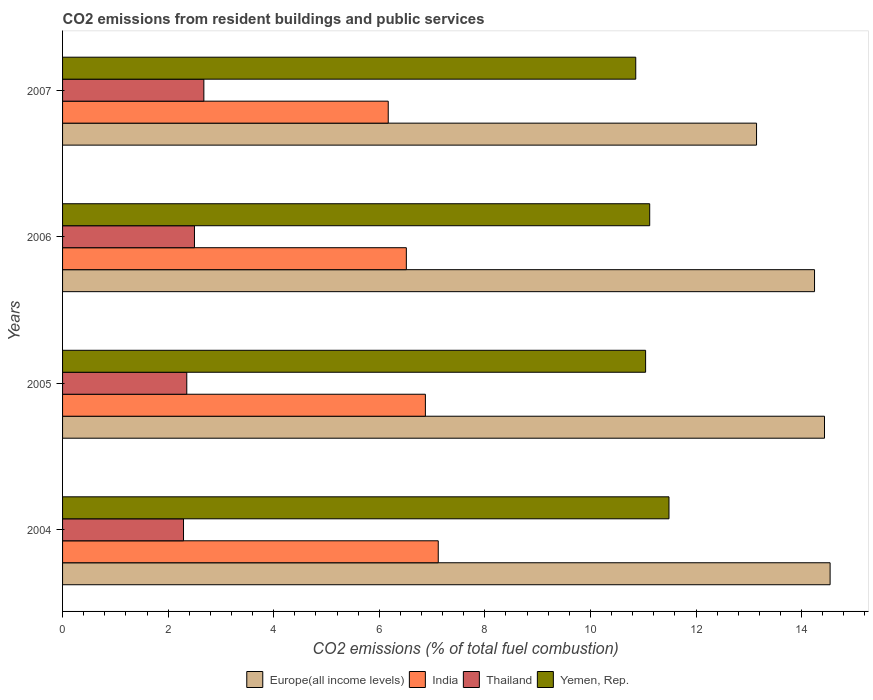Are the number of bars per tick equal to the number of legend labels?
Give a very brief answer. Yes. What is the total CO2 emitted in India in 2005?
Keep it short and to the point. 6.87. Across all years, what is the maximum total CO2 emitted in Europe(all income levels)?
Ensure brevity in your answer.  14.54. Across all years, what is the minimum total CO2 emitted in Yemen, Rep.?
Offer a terse response. 10.86. In which year was the total CO2 emitted in Yemen, Rep. maximum?
Your response must be concise. 2004. What is the total total CO2 emitted in Yemen, Rep. in the graph?
Make the answer very short. 44.52. What is the difference between the total CO2 emitted in India in 2004 and that in 2007?
Your response must be concise. 0.95. What is the difference between the total CO2 emitted in Europe(all income levels) in 2004 and the total CO2 emitted in Yemen, Rep. in 2006?
Offer a very short reply. 3.42. What is the average total CO2 emitted in India per year?
Offer a very short reply. 6.67. In the year 2007, what is the difference between the total CO2 emitted in Yemen, Rep. and total CO2 emitted in India?
Your answer should be compact. 4.69. What is the ratio of the total CO2 emitted in Yemen, Rep. in 2004 to that in 2005?
Your answer should be very brief. 1.04. Is the total CO2 emitted in India in 2004 less than that in 2007?
Ensure brevity in your answer.  No. Is the difference between the total CO2 emitted in Yemen, Rep. in 2004 and 2007 greater than the difference between the total CO2 emitted in India in 2004 and 2007?
Your answer should be very brief. No. What is the difference between the highest and the second highest total CO2 emitted in Europe(all income levels)?
Ensure brevity in your answer.  0.11. What is the difference between the highest and the lowest total CO2 emitted in Europe(all income levels)?
Your answer should be compact. 1.39. Is the sum of the total CO2 emitted in Europe(all income levels) in 2004 and 2006 greater than the maximum total CO2 emitted in Thailand across all years?
Your answer should be very brief. Yes. What does the 4th bar from the top in 2007 represents?
Provide a succinct answer. Europe(all income levels). Is it the case that in every year, the sum of the total CO2 emitted in Yemen, Rep. and total CO2 emitted in Europe(all income levels) is greater than the total CO2 emitted in India?
Make the answer very short. Yes. How many bars are there?
Make the answer very short. 16. How many years are there in the graph?
Offer a very short reply. 4. Are the values on the major ticks of X-axis written in scientific E-notation?
Make the answer very short. No. Does the graph contain any zero values?
Offer a terse response. No. Does the graph contain grids?
Give a very brief answer. No. How many legend labels are there?
Provide a short and direct response. 4. What is the title of the graph?
Ensure brevity in your answer.  CO2 emissions from resident buildings and public services. What is the label or title of the X-axis?
Make the answer very short. CO2 emissions (% of total fuel combustion). What is the CO2 emissions (% of total fuel combustion) of Europe(all income levels) in 2004?
Your answer should be compact. 14.54. What is the CO2 emissions (% of total fuel combustion) in India in 2004?
Give a very brief answer. 7.12. What is the CO2 emissions (% of total fuel combustion) of Thailand in 2004?
Provide a succinct answer. 2.29. What is the CO2 emissions (% of total fuel combustion) of Yemen, Rep. in 2004?
Your response must be concise. 11.49. What is the CO2 emissions (% of total fuel combustion) in Europe(all income levels) in 2005?
Your response must be concise. 14.43. What is the CO2 emissions (% of total fuel combustion) of India in 2005?
Provide a succinct answer. 6.87. What is the CO2 emissions (% of total fuel combustion) in Thailand in 2005?
Your answer should be very brief. 2.35. What is the CO2 emissions (% of total fuel combustion) of Yemen, Rep. in 2005?
Your response must be concise. 11.05. What is the CO2 emissions (% of total fuel combustion) in Europe(all income levels) in 2006?
Your answer should be compact. 14.25. What is the CO2 emissions (% of total fuel combustion) of India in 2006?
Offer a very short reply. 6.51. What is the CO2 emissions (% of total fuel combustion) in Thailand in 2006?
Offer a very short reply. 2.5. What is the CO2 emissions (% of total fuel combustion) in Yemen, Rep. in 2006?
Your answer should be compact. 11.12. What is the CO2 emissions (% of total fuel combustion) in Europe(all income levels) in 2007?
Your response must be concise. 13.15. What is the CO2 emissions (% of total fuel combustion) in India in 2007?
Provide a succinct answer. 6.17. What is the CO2 emissions (% of total fuel combustion) of Thailand in 2007?
Your answer should be compact. 2.68. What is the CO2 emissions (% of total fuel combustion) of Yemen, Rep. in 2007?
Offer a very short reply. 10.86. Across all years, what is the maximum CO2 emissions (% of total fuel combustion) in Europe(all income levels)?
Provide a short and direct response. 14.54. Across all years, what is the maximum CO2 emissions (% of total fuel combustion) in India?
Ensure brevity in your answer.  7.12. Across all years, what is the maximum CO2 emissions (% of total fuel combustion) in Thailand?
Give a very brief answer. 2.68. Across all years, what is the maximum CO2 emissions (% of total fuel combustion) of Yemen, Rep.?
Your answer should be very brief. 11.49. Across all years, what is the minimum CO2 emissions (% of total fuel combustion) in Europe(all income levels)?
Your answer should be compact. 13.15. Across all years, what is the minimum CO2 emissions (% of total fuel combustion) in India?
Ensure brevity in your answer.  6.17. Across all years, what is the minimum CO2 emissions (% of total fuel combustion) in Thailand?
Provide a succinct answer. 2.29. Across all years, what is the minimum CO2 emissions (% of total fuel combustion) in Yemen, Rep.?
Your answer should be very brief. 10.86. What is the total CO2 emissions (% of total fuel combustion) of Europe(all income levels) in the graph?
Your response must be concise. 56.37. What is the total CO2 emissions (% of total fuel combustion) in India in the graph?
Your answer should be very brief. 26.67. What is the total CO2 emissions (% of total fuel combustion) in Thailand in the graph?
Offer a very short reply. 9.82. What is the total CO2 emissions (% of total fuel combustion) of Yemen, Rep. in the graph?
Give a very brief answer. 44.52. What is the difference between the CO2 emissions (% of total fuel combustion) in Europe(all income levels) in 2004 and that in 2005?
Keep it short and to the point. 0.11. What is the difference between the CO2 emissions (% of total fuel combustion) in India in 2004 and that in 2005?
Your answer should be very brief. 0.24. What is the difference between the CO2 emissions (% of total fuel combustion) of Thailand in 2004 and that in 2005?
Offer a very short reply. -0.06. What is the difference between the CO2 emissions (% of total fuel combustion) of Yemen, Rep. in 2004 and that in 2005?
Offer a very short reply. 0.44. What is the difference between the CO2 emissions (% of total fuel combustion) of Europe(all income levels) in 2004 and that in 2006?
Offer a very short reply. 0.3. What is the difference between the CO2 emissions (% of total fuel combustion) of India in 2004 and that in 2006?
Give a very brief answer. 0.6. What is the difference between the CO2 emissions (% of total fuel combustion) of Thailand in 2004 and that in 2006?
Your response must be concise. -0.21. What is the difference between the CO2 emissions (% of total fuel combustion) of Yemen, Rep. in 2004 and that in 2006?
Provide a succinct answer. 0.37. What is the difference between the CO2 emissions (% of total fuel combustion) of Europe(all income levels) in 2004 and that in 2007?
Provide a short and direct response. 1.39. What is the difference between the CO2 emissions (% of total fuel combustion) of India in 2004 and that in 2007?
Provide a succinct answer. 0.95. What is the difference between the CO2 emissions (% of total fuel combustion) in Thailand in 2004 and that in 2007?
Provide a succinct answer. -0.39. What is the difference between the CO2 emissions (% of total fuel combustion) of Yemen, Rep. in 2004 and that in 2007?
Offer a terse response. 0.63. What is the difference between the CO2 emissions (% of total fuel combustion) of Europe(all income levels) in 2005 and that in 2006?
Offer a very short reply. 0.19. What is the difference between the CO2 emissions (% of total fuel combustion) of India in 2005 and that in 2006?
Give a very brief answer. 0.36. What is the difference between the CO2 emissions (% of total fuel combustion) in Thailand in 2005 and that in 2006?
Offer a very short reply. -0.15. What is the difference between the CO2 emissions (% of total fuel combustion) in Yemen, Rep. in 2005 and that in 2006?
Offer a very short reply. -0.08. What is the difference between the CO2 emissions (% of total fuel combustion) in Europe(all income levels) in 2005 and that in 2007?
Ensure brevity in your answer.  1.29. What is the difference between the CO2 emissions (% of total fuel combustion) of India in 2005 and that in 2007?
Your answer should be compact. 0.7. What is the difference between the CO2 emissions (% of total fuel combustion) of Thailand in 2005 and that in 2007?
Give a very brief answer. -0.32. What is the difference between the CO2 emissions (% of total fuel combustion) in Yemen, Rep. in 2005 and that in 2007?
Give a very brief answer. 0.19. What is the difference between the CO2 emissions (% of total fuel combustion) of Europe(all income levels) in 2006 and that in 2007?
Give a very brief answer. 1.1. What is the difference between the CO2 emissions (% of total fuel combustion) of India in 2006 and that in 2007?
Keep it short and to the point. 0.34. What is the difference between the CO2 emissions (% of total fuel combustion) of Thailand in 2006 and that in 2007?
Offer a very short reply. -0.18. What is the difference between the CO2 emissions (% of total fuel combustion) of Yemen, Rep. in 2006 and that in 2007?
Provide a short and direct response. 0.26. What is the difference between the CO2 emissions (% of total fuel combustion) in Europe(all income levels) in 2004 and the CO2 emissions (% of total fuel combustion) in India in 2005?
Make the answer very short. 7.67. What is the difference between the CO2 emissions (% of total fuel combustion) of Europe(all income levels) in 2004 and the CO2 emissions (% of total fuel combustion) of Thailand in 2005?
Provide a succinct answer. 12.19. What is the difference between the CO2 emissions (% of total fuel combustion) in Europe(all income levels) in 2004 and the CO2 emissions (% of total fuel combustion) in Yemen, Rep. in 2005?
Your response must be concise. 3.5. What is the difference between the CO2 emissions (% of total fuel combustion) in India in 2004 and the CO2 emissions (% of total fuel combustion) in Thailand in 2005?
Offer a very short reply. 4.76. What is the difference between the CO2 emissions (% of total fuel combustion) of India in 2004 and the CO2 emissions (% of total fuel combustion) of Yemen, Rep. in 2005?
Offer a terse response. -3.93. What is the difference between the CO2 emissions (% of total fuel combustion) of Thailand in 2004 and the CO2 emissions (% of total fuel combustion) of Yemen, Rep. in 2005?
Offer a terse response. -8.75. What is the difference between the CO2 emissions (% of total fuel combustion) in Europe(all income levels) in 2004 and the CO2 emissions (% of total fuel combustion) in India in 2006?
Provide a short and direct response. 8.03. What is the difference between the CO2 emissions (% of total fuel combustion) of Europe(all income levels) in 2004 and the CO2 emissions (% of total fuel combustion) of Thailand in 2006?
Ensure brevity in your answer.  12.04. What is the difference between the CO2 emissions (% of total fuel combustion) of Europe(all income levels) in 2004 and the CO2 emissions (% of total fuel combustion) of Yemen, Rep. in 2006?
Your answer should be compact. 3.42. What is the difference between the CO2 emissions (% of total fuel combustion) in India in 2004 and the CO2 emissions (% of total fuel combustion) in Thailand in 2006?
Your answer should be very brief. 4.62. What is the difference between the CO2 emissions (% of total fuel combustion) in India in 2004 and the CO2 emissions (% of total fuel combustion) in Yemen, Rep. in 2006?
Offer a very short reply. -4.01. What is the difference between the CO2 emissions (% of total fuel combustion) in Thailand in 2004 and the CO2 emissions (% of total fuel combustion) in Yemen, Rep. in 2006?
Offer a terse response. -8.83. What is the difference between the CO2 emissions (% of total fuel combustion) in Europe(all income levels) in 2004 and the CO2 emissions (% of total fuel combustion) in India in 2007?
Make the answer very short. 8.37. What is the difference between the CO2 emissions (% of total fuel combustion) of Europe(all income levels) in 2004 and the CO2 emissions (% of total fuel combustion) of Thailand in 2007?
Your answer should be compact. 11.86. What is the difference between the CO2 emissions (% of total fuel combustion) in Europe(all income levels) in 2004 and the CO2 emissions (% of total fuel combustion) in Yemen, Rep. in 2007?
Make the answer very short. 3.68. What is the difference between the CO2 emissions (% of total fuel combustion) in India in 2004 and the CO2 emissions (% of total fuel combustion) in Thailand in 2007?
Offer a terse response. 4.44. What is the difference between the CO2 emissions (% of total fuel combustion) of India in 2004 and the CO2 emissions (% of total fuel combustion) of Yemen, Rep. in 2007?
Provide a short and direct response. -3.74. What is the difference between the CO2 emissions (% of total fuel combustion) of Thailand in 2004 and the CO2 emissions (% of total fuel combustion) of Yemen, Rep. in 2007?
Your answer should be compact. -8.57. What is the difference between the CO2 emissions (% of total fuel combustion) in Europe(all income levels) in 2005 and the CO2 emissions (% of total fuel combustion) in India in 2006?
Your answer should be very brief. 7.92. What is the difference between the CO2 emissions (% of total fuel combustion) in Europe(all income levels) in 2005 and the CO2 emissions (% of total fuel combustion) in Thailand in 2006?
Your answer should be very brief. 11.94. What is the difference between the CO2 emissions (% of total fuel combustion) of Europe(all income levels) in 2005 and the CO2 emissions (% of total fuel combustion) of Yemen, Rep. in 2006?
Give a very brief answer. 3.31. What is the difference between the CO2 emissions (% of total fuel combustion) in India in 2005 and the CO2 emissions (% of total fuel combustion) in Thailand in 2006?
Your answer should be very brief. 4.37. What is the difference between the CO2 emissions (% of total fuel combustion) of India in 2005 and the CO2 emissions (% of total fuel combustion) of Yemen, Rep. in 2006?
Your answer should be very brief. -4.25. What is the difference between the CO2 emissions (% of total fuel combustion) of Thailand in 2005 and the CO2 emissions (% of total fuel combustion) of Yemen, Rep. in 2006?
Offer a very short reply. -8.77. What is the difference between the CO2 emissions (% of total fuel combustion) of Europe(all income levels) in 2005 and the CO2 emissions (% of total fuel combustion) of India in 2007?
Provide a succinct answer. 8.26. What is the difference between the CO2 emissions (% of total fuel combustion) in Europe(all income levels) in 2005 and the CO2 emissions (% of total fuel combustion) in Thailand in 2007?
Your response must be concise. 11.76. What is the difference between the CO2 emissions (% of total fuel combustion) in Europe(all income levels) in 2005 and the CO2 emissions (% of total fuel combustion) in Yemen, Rep. in 2007?
Your response must be concise. 3.58. What is the difference between the CO2 emissions (% of total fuel combustion) in India in 2005 and the CO2 emissions (% of total fuel combustion) in Thailand in 2007?
Offer a terse response. 4.2. What is the difference between the CO2 emissions (% of total fuel combustion) of India in 2005 and the CO2 emissions (% of total fuel combustion) of Yemen, Rep. in 2007?
Your answer should be very brief. -3.99. What is the difference between the CO2 emissions (% of total fuel combustion) of Thailand in 2005 and the CO2 emissions (% of total fuel combustion) of Yemen, Rep. in 2007?
Give a very brief answer. -8.51. What is the difference between the CO2 emissions (% of total fuel combustion) of Europe(all income levels) in 2006 and the CO2 emissions (% of total fuel combustion) of India in 2007?
Your response must be concise. 8.08. What is the difference between the CO2 emissions (% of total fuel combustion) of Europe(all income levels) in 2006 and the CO2 emissions (% of total fuel combustion) of Thailand in 2007?
Give a very brief answer. 11.57. What is the difference between the CO2 emissions (% of total fuel combustion) in Europe(all income levels) in 2006 and the CO2 emissions (% of total fuel combustion) in Yemen, Rep. in 2007?
Offer a terse response. 3.39. What is the difference between the CO2 emissions (% of total fuel combustion) in India in 2006 and the CO2 emissions (% of total fuel combustion) in Thailand in 2007?
Your answer should be very brief. 3.84. What is the difference between the CO2 emissions (% of total fuel combustion) in India in 2006 and the CO2 emissions (% of total fuel combustion) in Yemen, Rep. in 2007?
Provide a succinct answer. -4.35. What is the difference between the CO2 emissions (% of total fuel combustion) in Thailand in 2006 and the CO2 emissions (% of total fuel combustion) in Yemen, Rep. in 2007?
Your answer should be compact. -8.36. What is the average CO2 emissions (% of total fuel combustion) of Europe(all income levels) per year?
Offer a very short reply. 14.09. What is the average CO2 emissions (% of total fuel combustion) of India per year?
Your answer should be compact. 6.67. What is the average CO2 emissions (% of total fuel combustion) of Thailand per year?
Make the answer very short. 2.46. What is the average CO2 emissions (% of total fuel combustion) of Yemen, Rep. per year?
Your answer should be compact. 11.13. In the year 2004, what is the difference between the CO2 emissions (% of total fuel combustion) of Europe(all income levels) and CO2 emissions (% of total fuel combustion) of India?
Offer a terse response. 7.42. In the year 2004, what is the difference between the CO2 emissions (% of total fuel combustion) in Europe(all income levels) and CO2 emissions (% of total fuel combustion) in Thailand?
Provide a short and direct response. 12.25. In the year 2004, what is the difference between the CO2 emissions (% of total fuel combustion) in Europe(all income levels) and CO2 emissions (% of total fuel combustion) in Yemen, Rep.?
Offer a terse response. 3.05. In the year 2004, what is the difference between the CO2 emissions (% of total fuel combustion) of India and CO2 emissions (% of total fuel combustion) of Thailand?
Keep it short and to the point. 4.83. In the year 2004, what is the difference between the CO2 emissions (% of total fuel combustion) in India and CO2 emissions (% of total fuel combustion) in Yemen, Rep.?
Offer a terse response. -4.37. In the year 2004, what is the difference between the CO2 emissions (% of total fuel combustion) in Thailand and CO2 emissions (% of total fuel combustion) in Yemen, Rep.?
Your response must be concise. -9.2. In the year 2005, what is the difference between the CO2 emissions (% of total fuel combustion) of Europe(all income levels) and CO2 emissions (% of total fuel combustion) of India?
Make the answer very short. 7.56. In the year 2005, what is the difference between the CO2 emissions (% of total fuel combustion) of Europe(all income levels) and CO2 emissions (% of total fuel combustion) of Thailand?
Ensure brevity in your answer.  12.08. In the year 2005, what is the difference between the CO2 emissions (% of total fuel combustion) in Europe(all income levels) and CO2 emissions (% of total fuel combustion) in Yemen, Rep.?
Offer a very short reply. 3.39. In the year 2005, what is the difference between the CO2 emissions (% of total fuel combustion) of India and CO2 emissions (% of total fuel combustion) of Thailand?
Provide a succinct answer. 4.52. In the year 2005, what is the difference between the CO2 emissions (% of total fuel combustion) of India and CO2 emissions (% of total fuel combustion) of Yemen, Rep.?
Your answer should be compact. -4.17. In the year 2005, what is the difference between the CO2 emissions (% of total fuel combustion) in Thailand and CO2 emissions (% of total fuel combustion) in Yemen, Rep.?
Offer a very short reply. -8.69. In the year 2006, what is the difference between the CO2 emissions (% of total fuel combustion) of Europe(all income levels) and CO2 emissions (% of total fuel combustion) of India?
Ensure brevity in your answer.  7.73. In the year 2006, what is the difference between the CO2 emissions (% of total fuel combustion) in Europe(all income levels) and CO2 emissions (% of total fuel combustion) in Thailand?
Your answer should be compact. 11.75. In the year 2006, what is the difference between the CO2 emissions (% of total fuel combustion) of Europe(all income levels) and CO2 emissions (% of total fuel combustion) of Yemen, Rep.?
Offer a terse response. 3.12. In the year 2006, what is the difference between the CO2 emissions (% of total fuel combustion) in India and CO2 emissions (% of total fuel combustion) in Thailand?
Provide a short and direct response. 4.01. In the year 2006, what is the difference between the CO2 emissions (% of total fuel combustion) in India and CO2 emissions (% of total fuel combustion) in Yemen, Rep.?
Keep it short and to the point. -4.61. In the year 2006, what is the difference between the CO2 emissions (% of total fuel combustion) in Thailand and CO2 emissions (% of total fuel combustion) in Yemen, Rep.?
Offer a very short reply. -8.62. In the year 2007, what is the difference between the CO2 emissions (% of total fuel combustion) in Europe(all income levels) and CO2 emissions (% of total fuel combustion) in India?
Provide a short and direct response. 6.98. In the year 2007, what is the difference between the CO2 emissions (% of total fuel combustion) of Europe(all income levels) and CO2 emissions (% of total fuel combustion) of Thailand?
Your answer should be compact. 10.47. In the year 2007, what is the difference between the CO2 emissions (% of total fuel combustion) of Europe(all income levels) and CO2 emissions (% of total fuel combustion) of Yemen, Rep.?
Give a very brief answer. 2.29. In the year 2007, what is the difference between the CO2 emissions (% of total fuel combustion) in India and CO2 emissions (% of total fuel combustion) in Thailand?
Your answer should be compact. 3.49. In the year 2007, what is the difference between the CO2 emissions (% of total fuel combustion) of India and CO2 emissions (% of total fuel combustion) of Yemen, Rep.?
Provide a short and direct response. -4.69. In the year 2007, what is the difference between the CO2 emissions (% of total fuel combustion) of Thailand and CO2 emissions (% of total fuel combustion) of Yemen, Rep.?
Offer a very short reply. -8.18. What is the ratio of the CO2 emissions (% of total fuel combustion) of Europe(all income levels) in 2004 to that in 2005?
Your answer should be compact. 1.01. What is the ratio of the CO2 emissions (% of total fuel combustion) in India in 2004 to that in 2005?
Your response must be concise. 1.04. What is the ratio of the CO2 emissions (% of total fuel combustion) of Thailand in 2004 to that in 2005?
Give a very brief answer. 0.97. What is the ratio of the CO2 emissions (% of total fuel combustion) in Yemen, Rep. in 2004 to that in 2005?
Your response must be concise. 1.04. What is the ratio of the CO2 emissions (% of total fuel combustion) in Europe(all income levels) in 2004 to that in 2006?
Your answer should be very brief. 1.02. What is the ratio of the CO2 emissions (% of total fuel combustion) of India in 2004 to that in 2006?
Your answer should be very brief. 1.09. What is the ratio of the CO2 emissions (% of total fuel combustion) in Thailand in 2004 to that in 2006?
Provide a short and direct response. 0.92. What is the ratio of the CO2 emissions (% of total fuel combustion) in Yemen, Rep. in 2004 to that in 2006?
Provide a succinct answer. 1.03. What is the ratio of the CO2 emissions (% of total fuel combustion) of Europe(all income levels) in 2004 to that in 2007?
Offer a very short reply. 1.11. What is the ratio of the CO2 emissions (% of total fuel combustion) of India in 2004 to that in 2007?
Give a very brief answer. 1.15. What is the ratio of the CO2 emissions (% of total fuel combustion) in Thailand in 2004 to that in 2007?
Offer a terse response. 0.86. What is the ratio of the CO2 emissions (% of total fuel combustion) of Yemen, Rep. in 2004 to that in 2007?
Your response must be concise. 1.06. What is the ratio of the CO2 emissions (% of total fuel combustion) in Europe(all income levels) in 2005 to that in 2006?
Make the answer very short. 1.01. What is the ratio of the CO2 emissions (% of total fuel combustion) in India in 2005 to that in 2006?
Give a very brief answer. 1.06. What is the ratio of the CO2 emissions (% of total fuel combustion) of Thailand in 2005 to that in 2006?
Offer a very short reply. 0.94. What is the ratio of the CO2 emissions (% of total fuel combustion) of Europe(all income levels) in 2005 to that in 2007?
Ensure brevity in your answer.  1.1. What is the ratio of the CO2 emissions (% of total fuel combustion) of India in 2005 to that in 2007?
Provide a succinct answer. 1.11. What is the ratio of the CO2 emissions (% of total fuel combustion) of Thailand in 2005 to that in 2007?
Provide a short and direct response. 0.88. What is the ratio of the CO2 emissions (% of total fuel combustion) in Yemen, Rep. in 2005 to that in 2007?
Your answer should be very brief. 1.02. What is the ratio of the CO2 emissions (% of total fuel combustion) in Europe(all income levels) in 2006 to that in 2007?
Offer a terse response. 1.08. What is the ratio of the CO2 emissions (% of total fuel combustion) of India in 2006 to that in 2007?
Make the answer very short. 1.06. What is the ratio of the CO2 emissions (% of total fuel combustion) in Thailand in 2006 to that in 2007?
Ensure brevity in your answer.  0.93. What is the ratio of the CO2 emissions (% of total fuel combustion) in Yemen, Rep. in 2006 to that in 2007?
Your answer should be compact. 1.02. What is the difference between the highest and the second highest CO2 emissions (% of total fuel combustion) in Europe(all income levels)?
Make the answer very short. 0.11. What is the difference between the highest and the second highest CO2 emissions (% of total fuel combustion) in India?
Offer a terse response. 0.24. What is the difference between the highest and the second highest CO2 emissions (% of total fuel combustion) of Thailand?
Your answer should be very brief. 0.18. What is the difference between the highest and the second highest CO2 emissions (% of total fuel combustion) of Yemen, Rep.?
Provide a succinct answer. 0.37. What is the difference between the highest and the lowest CO2 emissions (% of total fuel combustion) in Europe(all income levels)?
Your answer should be compact. 1.39. What is the difference between the highest and the lowest CO2 emissions (% of total fuel combustion) of India?
Your response must be concise. 0.95. What is the difference between the highest and the lowest CO2 emissions (% of total fuel combustion) of Thailand?
Ensure brevity in your answer.  0.39. What is the difference between the highest and the lowest CO2 emissions (% of total fuel combustion) of Yemen, Rep.?
Your response must be concise. 0.63. 